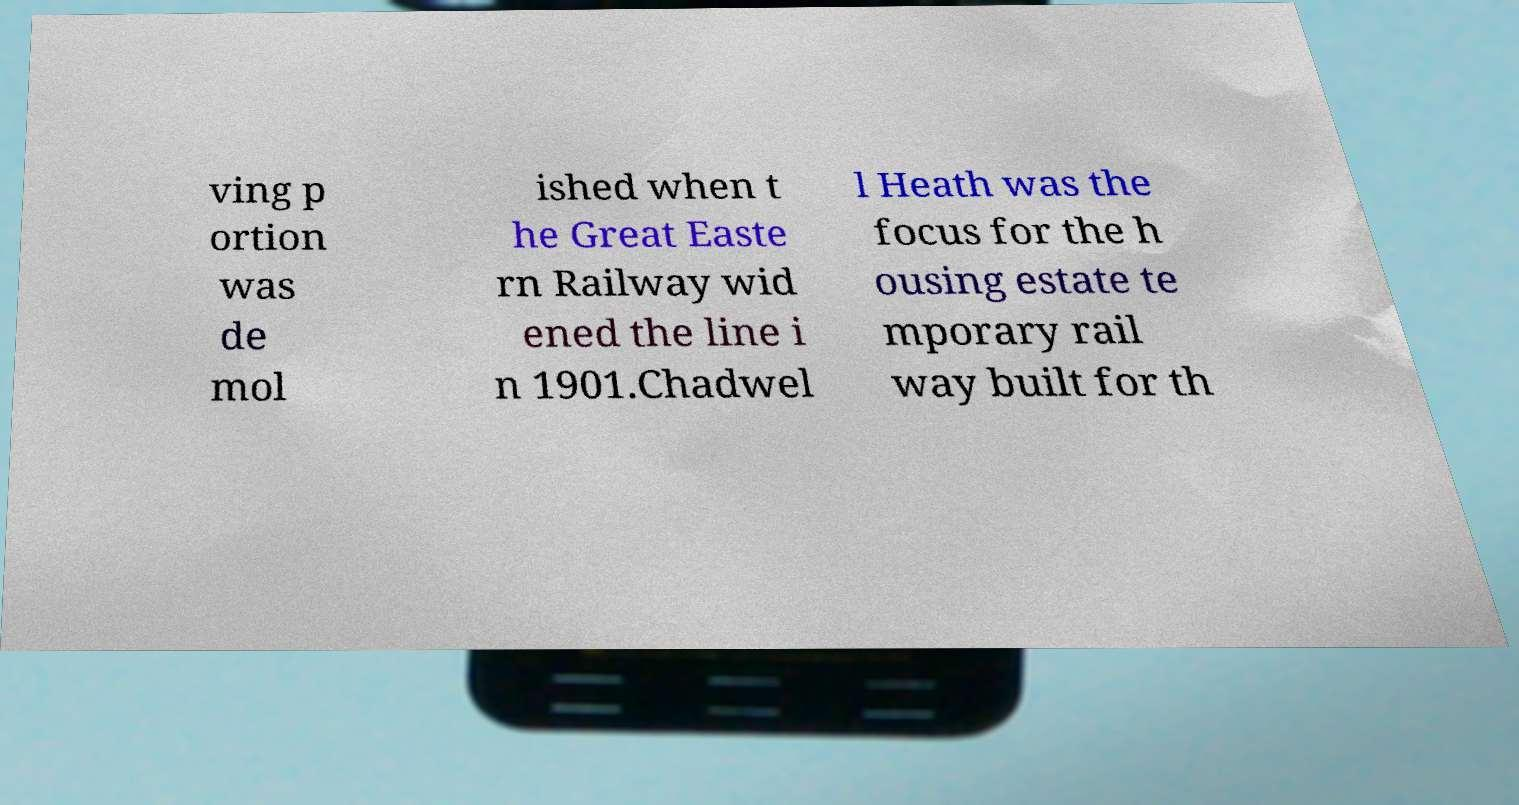For documentation purposes, I need the text within this image transcribed. Could you provide that? ving p ortion was de mol ished when t he Great Easte rn Railway wid ened the line i n 1901.Chadwel l Heath was the focus for the h ousing estate te mporary rail way built for th 